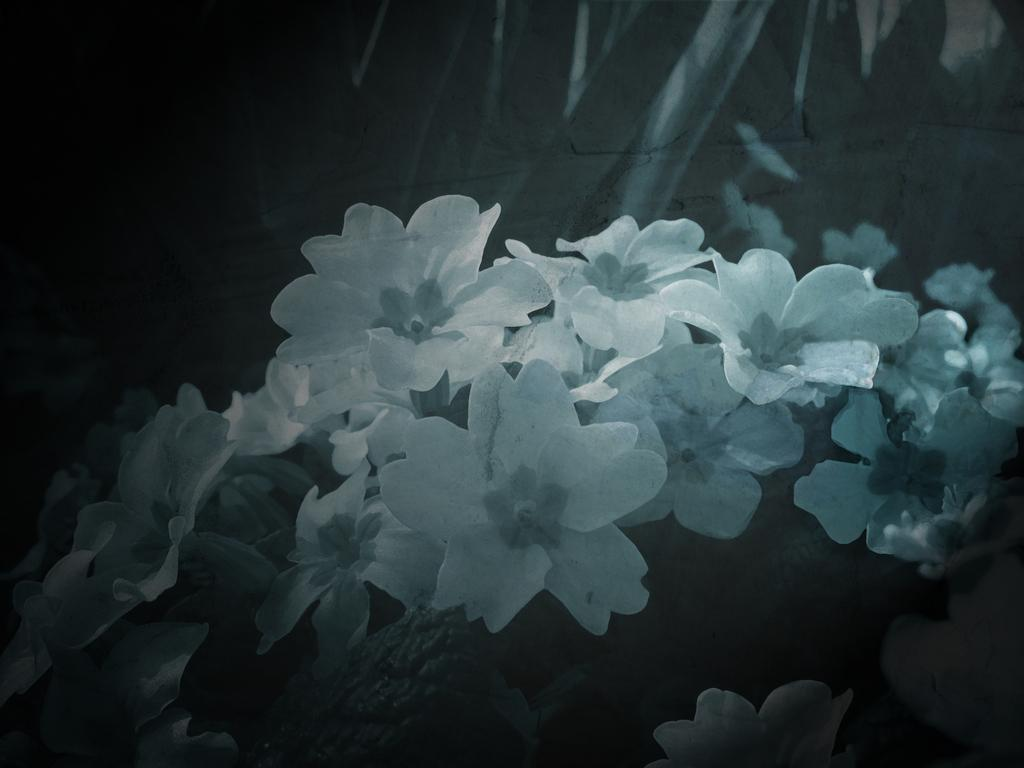What type of flowers can be seen in the image? There are white color flowers in the image. Can you describe the overall lighting or brightness of the image? The image is slightly dark. What type of territory is being claimed by the flowers in the image? The flowers in the image are not claiming any territory; they are simply flowers. 